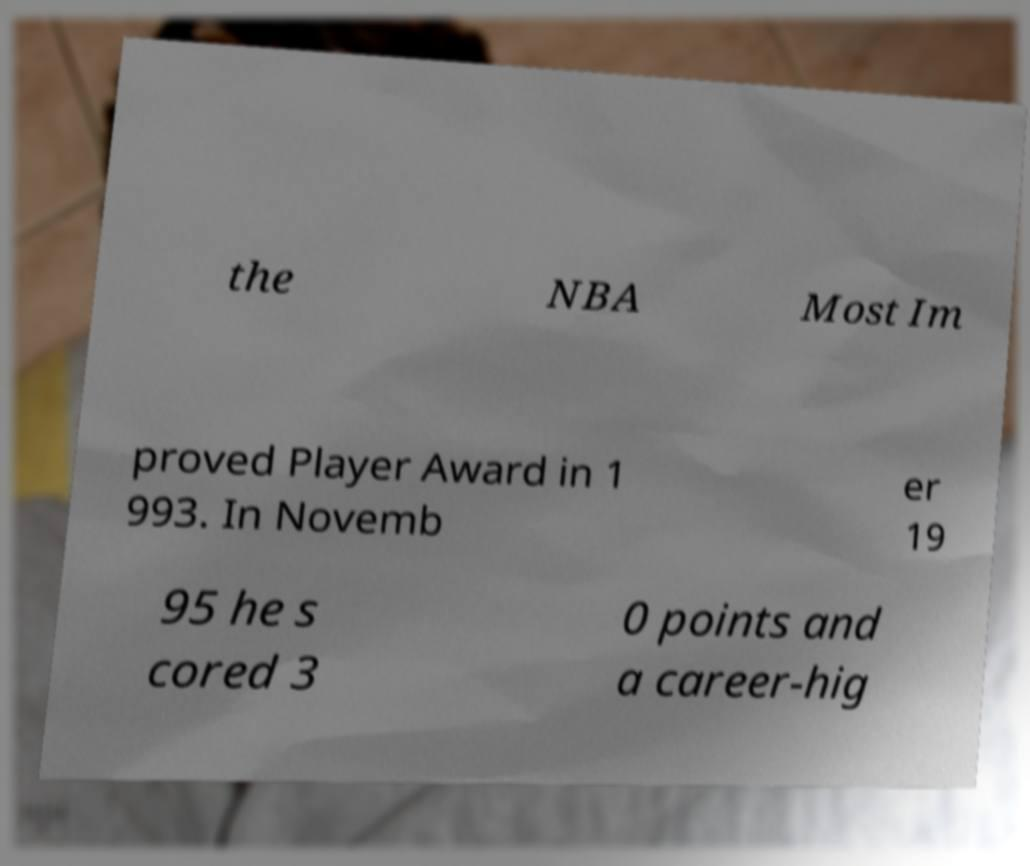For documentation purposes, I need the text within this image transcribed. Could you provide that? the NBA Most Im proved Player Award in 1 993. In Novemb er 19 95 he s cored 3 0 points and a career-hig 